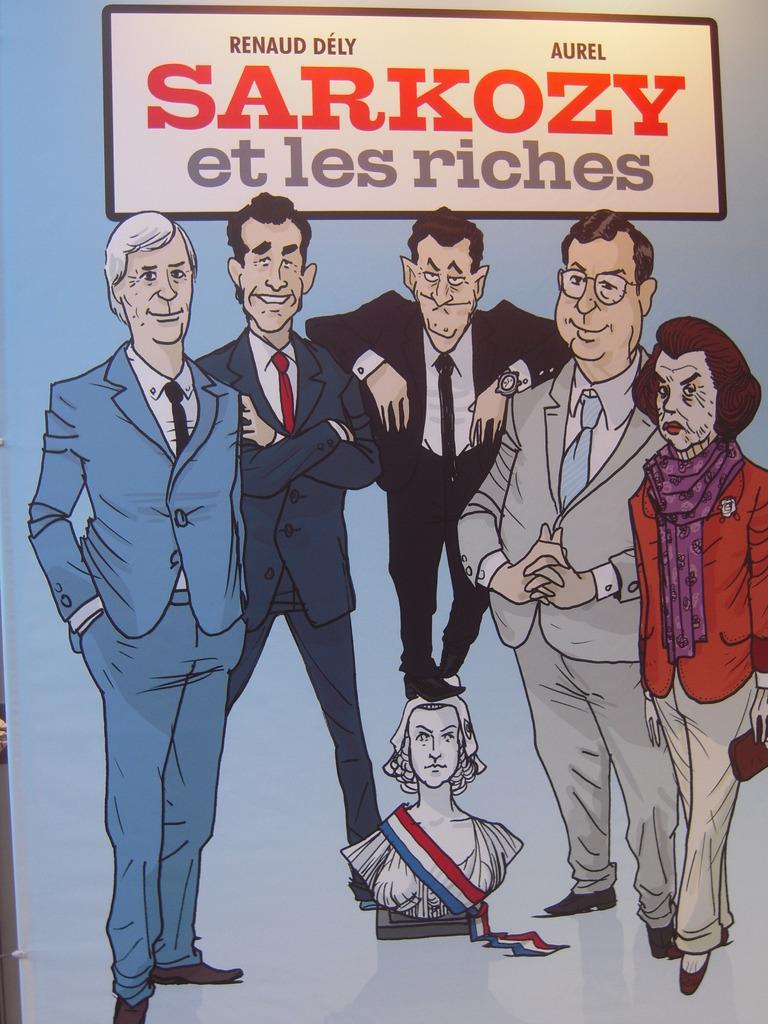Could you give a brief overview of what you see in this image? Here we can see a poster. On this poster there are animated people. Above this people there is a boat. Here we can see a statue. 